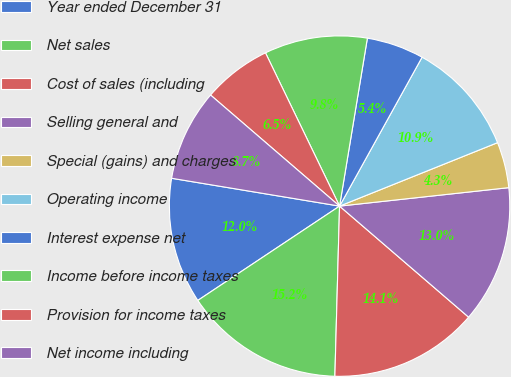Convert chart to OTSL. <chart><loc_0><loc_0><loc_500><loc_500><pie_chart><fcel>Year ended December 31<fcel>Net sales<fcel>Cost of sales (including<fcel>Selling general and<fcel>Special (gains) and charges<fcel>Operating income<fcel>Interest expense net<fcel>Income before income taxes<fcel>Provision for income taxes<fcel>Net income including<nl><fcel>11.96%<fcel>15.22%<fcel>14.13%<fcel>13.04%<fcel>4.35%<fcel>10.87%<fcel>5.44%<fcel>9.78%<fcel>6.52%<fcel>8.7%<nl></chart> 